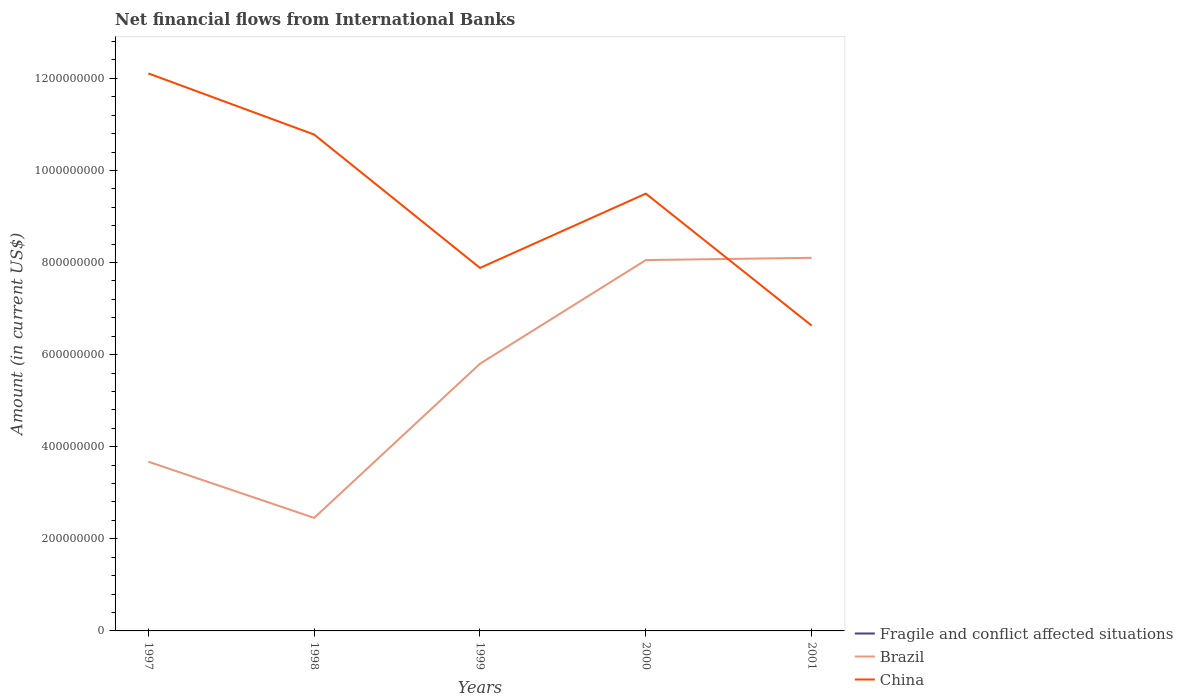Does the line corresponding to Brazil intersect with the line corresponding to China?
Offer a very short reply. Yes. Across all years, what is the maximum net financial aid flows in Brazil?
Give a very brief answer. 2.46e+08. What is the total net financial aid flows in Brazil in the graph?
Your answer should be compact. -3.35e+08. What is the difference between the highest and the second highest net financial aid flows in China?
Keep it short and to the point. 5.48e+08. How many lines are there?
Your answer should be compact. 2. How many years are there in the graph?
Provide a short and direct response. 5. Are the values on the major ticks of Y-axis written in scientific E-notation?
Provide a succinct answer. No. Does the graph contain any zero values?
Offer a terse response. Yes. Where does the legend appear in the graph?
Give a very brief answer. Bottom right. How many legend labels are there?
Provide a succinct answer. 3. What is the title of the graph?
Ensure brevity in your answer.  Net financial flows from International Banks. What is the label or title of the X-axis?
Your answer should be very brief. Years. What is the Amount (in current US$) of Brazil in 1997?
Ensure brevity in your answer.  3.68e+08. What is the Amount (in current US$) in China in 1997?
Offer a very short reply. 1.21e+09. What is the Amount (in current US$) of Brazil in 1998?
Keep it short and to the point. 2.46e+08. What is the Amount (in current US$) of China in 1998?
Provide a succinct answer. 1.08e+09. What is the Amount (in current US$) in Brazil in 1999?
Keep it short and to the point. 5.80e+08. What is the Amount (in current US$) in China in 1999?
Ensure brevity in your answer.  7.88e+08. What is the Amount (in current US$) of Fragile and conflict affected situations in 2000?
Provide a short and direct response. 0. What is the Amount (in current US$) of Brazil in 2000?
Give a very brief answer. 8.05e+08. What is the Amount (in current US$) in China in 2000?
Make the answer very short. 9.50e+08. What is the Amount (in current US$) in Fragile and conflict affected situations in 2001?
Your answer should be very brief. 0. What is the Amount (in current US$) of Brazil in 2001?
Your answer should be very brief. 8.10e+08. What is the Amount (in current US$) of China in 2001?
Provide a short and direct response. 6.63e+08. Across all years, what is the maximum Amount (in current US$) of Brazil?
Your answer should be compact. 8.10e+08. Across all years, what is the maximum Amount (in current US$) of China?
Make the answer very short. 1.21e+09. Across all years, what is the minimum Amount (in current US$) in Brazil?
Provide a succinct answer. 2.46e+08. Across all years, what is the minimum Amount (in current US$) in China?
Your answer should be compact. 6.63e+08. What is the total Amount (in current US$) of Fragile and conflict affected situations in the graph?
Your response must be concise. 0. What is the total Amount (in current US$) in Brazil in the graph?
Provide a succinct answer. 2.81e+09. What is the total Amount (in current US$) of China in the graph?
Offer a terse response. 4.69e+09. What is the difference between the Amount (in current US$) in Brazil in 1997 and that in 1998?
Your response must be concise. 1.22e+08. What is the difference between the Amount (in current US$) of China in 1997 and that in 1998?
Give a very brief answer. 1.33e+08. What is the difference between the Amount (in current US$) of Brazil in 1997 and that in 1999?
Provide a succinct answer. -2.13e+08. What is the difference between the Amount (in current US$) of China in 1997 and that in 1999?
Provide a short and direct response. 4.22e+08. What is the difference between the Amount (in current US$) of Brazil in 1997 and that in 2000?
Ensure brevity in your answer.  -4.38e+08. What is the difference between the Amount (in current US$) of China in 1997 and that in 2000?
Keep it short and to the point. 2.61e+08. What is the difference between the Amount (in current US$) in Brazil in 1997 and that in 2001?
Your answer should be compact. -4.43e+08. What is the difference between the Amount (in current US$) of China in 1997 and that in 2001?
Make the answer very short. 5.48e+08. What is the difference between the Amount (in current US$) of Brazil in 1998 and that in 1999?
Your answer should be very brief. -3.35e+08. What is the difference between the Amount (in current US$) in China in 1998 and that in 1999?
Your answer should be compact. 2.90e+08. What is the difference between the Amount (in current US$) in Brazil in 1998 and that in 2000?
Offer a very short reply. -5.60e+08. What is the difference between the Amount (in current US$) in China in 1998 and that in 2000?
Make the answer very short. 1.28e+08. What is the difference between the Amount (in current US$) of Brazil in 1998 and that in 2001?
Your answer should be compact. -5.65e+08. What is the difference between the Amount (in current US$) in China in 1998 and that in 2001?
Ensure brevity in your answer.  4.15e+08. What is the difference between the Amount (in current US$) in Brazil in 1999 and that in 2000?
Offer a terse response. -2.25e+08. What is the difference between the Amount (in current US$) in China in 1999 and that in 2000?
Your answer should be very brief. -1.61e+08. What is the difference between the Amount (in current US$) of Brazil in 1999 and that in 2001?
Offer a terse response. -2.30e+08. What is the difference between the Amount (in current US$) of China in 1999 and that in 2001?
Your answer should be compact. 1.25e+08. What is the difference between the Amount (in current US$) in Brazil in 2000 and that in 2001?
Provide a short and direct response. -4.84e+06. What is the difference between the Amount (in current US$) of China in 2000 and that in 2001?
Make the answer very short. 2.87e+08. What is the difference between the Amount (in current US$) of Brazil in 1997 and the Amount (in current US$) of China in 1998?
Offer a very short reply. -7.10e+08. What is the difference between the Amount (in current US$) of Brazil in 1997 and the Amount (in current US$) of China in 1999?
Provide a short and direct response. -4.21e+08. What is the difference between the Amount (in current US$) of Brazil in 1997 and the Amount (in current US$) of China in 2000?
Your answer should be very brief. -5.82e+08. What is the difference between the Amount (in current US$) in Brazil in 1997 and the Amount (in current US$) in China in 2001?
Provide a short and direct response. -2.96e+08. What is the difference between the Amount (in current US$) of Brazil in 1998 and the Amount (in current US$) of China in 1999?
Your answer should be very brief. -5.43e+08. What is the difference between the Amount (in current US$) in Brazil in 1998 and the Amount (in current US$) in China in 2000?
Offer a terse response. -7.04e+08. What is the difference between the Amount (in current US$) in Brazil in 1998 and the Amount (in current US$) in China in 2001?
Provide a succinct answer. -4.18e+08. What is the difference between the Amount (in current US$) of Brazil in 1999 and the Amount (in current US$) of China in 2000?
Keep it short and to the point. -3.69e+08. What is the difference between the Amount (in current US$) of Brazil in 1999 and the Amount (in current US$) of China in 2001?
Provide a succinct answer. -8.28e+07. What is the difference between the Amount (in current US$) in Brazil in 2000 and the Amount (in current US$) in China in 2001?
Your response must be concise. 1.42e+08. What is the average Amount (in current US$) of Brazil per year?
Offer a very short reply. 5.62e+08. What is the average Amount (in current US$) of China per year?
Your response must be concise. 9.38e+08. In the year 1997, what is the difference between the Amount (in current US$) of Brazil and Amount (in current US$) of China?
Your answer should be compact. -8.43e+08. In the year 1998, what is the difference between the Amount (in current US$) in Brazil and Amount (in current US$) in China?
Ensure brevity in your answer.  -8.32e+08. In the year 1999, what is the difference between the Amount (in current US$) in Brazil and Amount (in current US$) in China?
Keep it short and to the point. -2.08e+08. In the year 2000, what is the difference between the Amount (in current US$) in Brazil and Amount (in current US$) in China?
Provide a succinct answer. -1.44e+08. In the year 2001, what is the difference between the Amount (in current US$) in Brazil and Amount (in current US$) in China?
Provide a succinct answer. 1.47e+08. What is the ratio of the Amount (in current US$) in Brazil in 1997 to that in 1998?
Your answer should be compact. 1.5. What is the ratio of the Amount (in current US$) of China in 1997 to that in 1998?
Keep it short and to the point. 1.12. What is the ratio of the Amount (in current US$) in Brazil in 1997 to that in 1999?
Your response must be concise. 0.63. What is the ratio of the Amount (in current US$) of China in 1997 to that in 1999?
Your answer should be compact. 1.54. What is the ratio of the Amount (in current US$) in Brazil in 1997 to that in 2000?
Your response must be concise. 0.46. What is the ratio of the Amount (in current US$) in China in 1997 to that in 2000?
Provide a succinct answer. 1.27. What is the ratio of the Amount (in current US$) of Brazil in 1997 to that in 2001?
Ensure brevity in your answer.  0.45. What is the ratio of the Amount (in current US$) of China in 1997 to that in 2001?
Offer a very short reply. 1.83. What is the ratio of the Amount (in current US$) in Brazil in 1998 to that in 1999?
Make the answer very short. 0.42. What is the ratio of the Amount (in current US$) in China in 1998 to that in 1999?
Offer a very short reply. 1.37. What is the ratio of the Amount (in current US$) in Brazil in 1998 to that in 2000?
Give a very brief answer. 0.3. What is the ratio of the Amount (in current US$) in China in 1998 to that in 2000?
Your answer should be compact. 1.14. What is the ratio of the Amount (in current US$) of Brazil in 1998 to that in 2001?
Keep it short and to the point. 0.3. What is the ratio of the Amount (in current US$) in China in 1998 to that in 2001?
Provide a succinct answer. 1.63. What is the ratio of the Amount (in current US$) of Brazil in 1999 to that in 2000?
Your answer should be very brief. 0.72. What is the ratio of the Amount (in current US$) in China in 1999 to that in 2000?
Your answer should be compact. 0.83. What is the ratio of the Amount (in current US$) of Brazil in 1999 to that in 2001?
Your response must be concise. 0.72. What is the ratio of the Amount (in current US$) in China in 1999 to that in 2001?
Provide a succinct answer. 1.19. What is the ratio of the Amount (in current US$) in Brazil in 2000 to that in 2001?
Your response must be concise. 0.99. What is the ratio of the Amount (in current US$) of China in 2000 to that in 2001?
Offer a very short reply. 1.43. What is the difference between the highest and the second highest Amount (in current US$) in Brazil?
Ensure brevity in your answer.  4.84e+06. What is the difference between the highest and the second highest Amount (in current US$) in China?
Offer a very short reply. 1.33e+08. What is the difference between the highest and the lowest Amount (in current US$) of Brazil?
Make the answer very short. 5.65e+08. What is the difference between the highest and the lowest Amount (in current US$) of China?
Keep it short and to the point. 5.48e+08. 